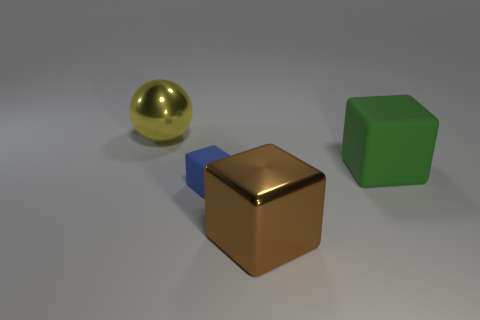What do the different textures of the objects tell us about their characteristics? The varying textures of the objects offer clues about their material properties. The reflective sphere's smooth surface suggests a hard, non-porous material like metal, the cube with a matte finish hints at being metallic, and the green cube has a plastic-like appearance that is opaque and absorbs light in a way that differentiates it from the others. 